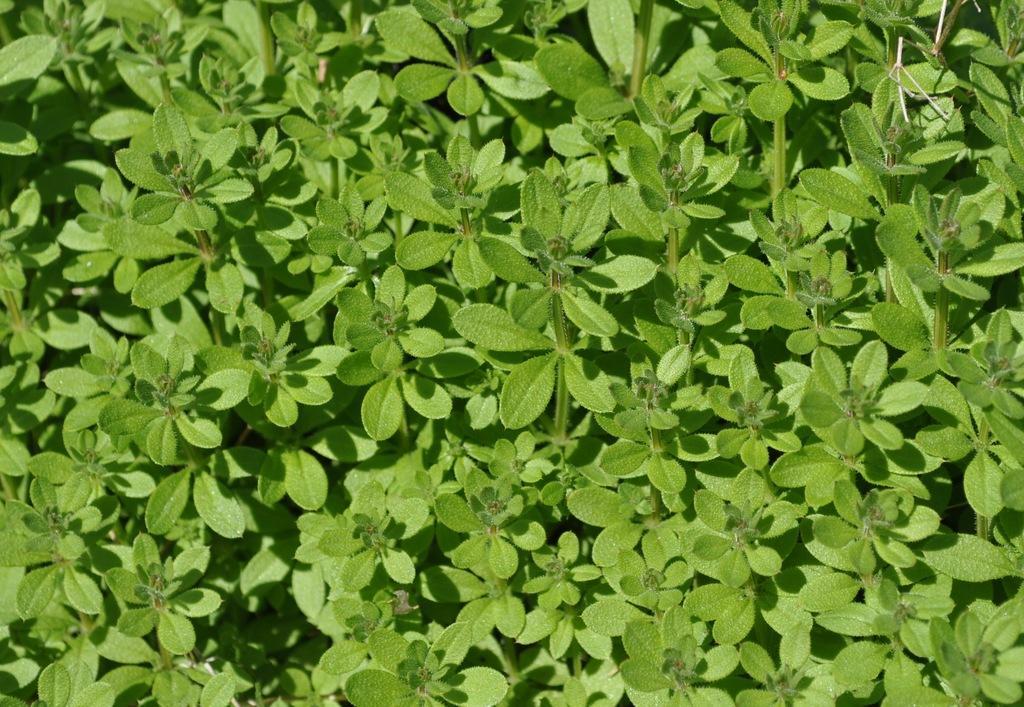Describe this image in one or two sentences. In this image we can see some herbs. 